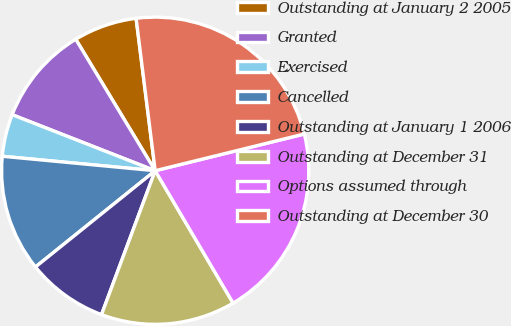Convert chart. <chart><loc_0><loc_0><loc_500><loc_500><pie_chart><fcel>Outstanding at January 2 2005<fcel>Granted<fcel>Exercised<fcel>Cancelled<fcel>Outstanding at January 1 2006<fcel>Outstanding at December 31<fcel>Options assumed through<fcel>Outstanding at December 30<nl><fcel>6.67%<fcel>10.41%<fcel>4.44%<fcel>12.28%<fcel>8.54%<fcel>14.15%<fcel>20.38%<fcel>23.14%<nl></chart> 